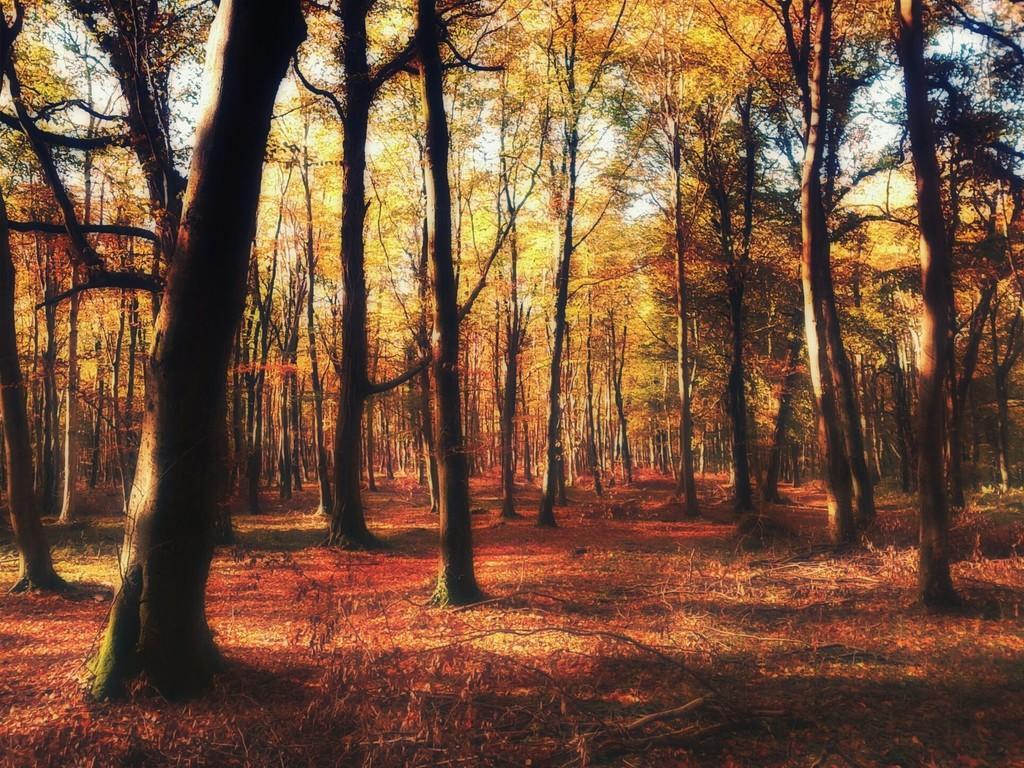What type of vegetation is present at the bottom of the image? There are dry leaves, grass, and stems at the bottom of the image. What can be seen in the center of the image? There are trees in the center of the image. What type of salt can be seen on the trees in the image? There is no salt present in the image; it features dry leaves, grass, stems, and trees. What type of joke is being told by the crowd in the image? There is no crowd present in the image, and therefore no joke being told. 